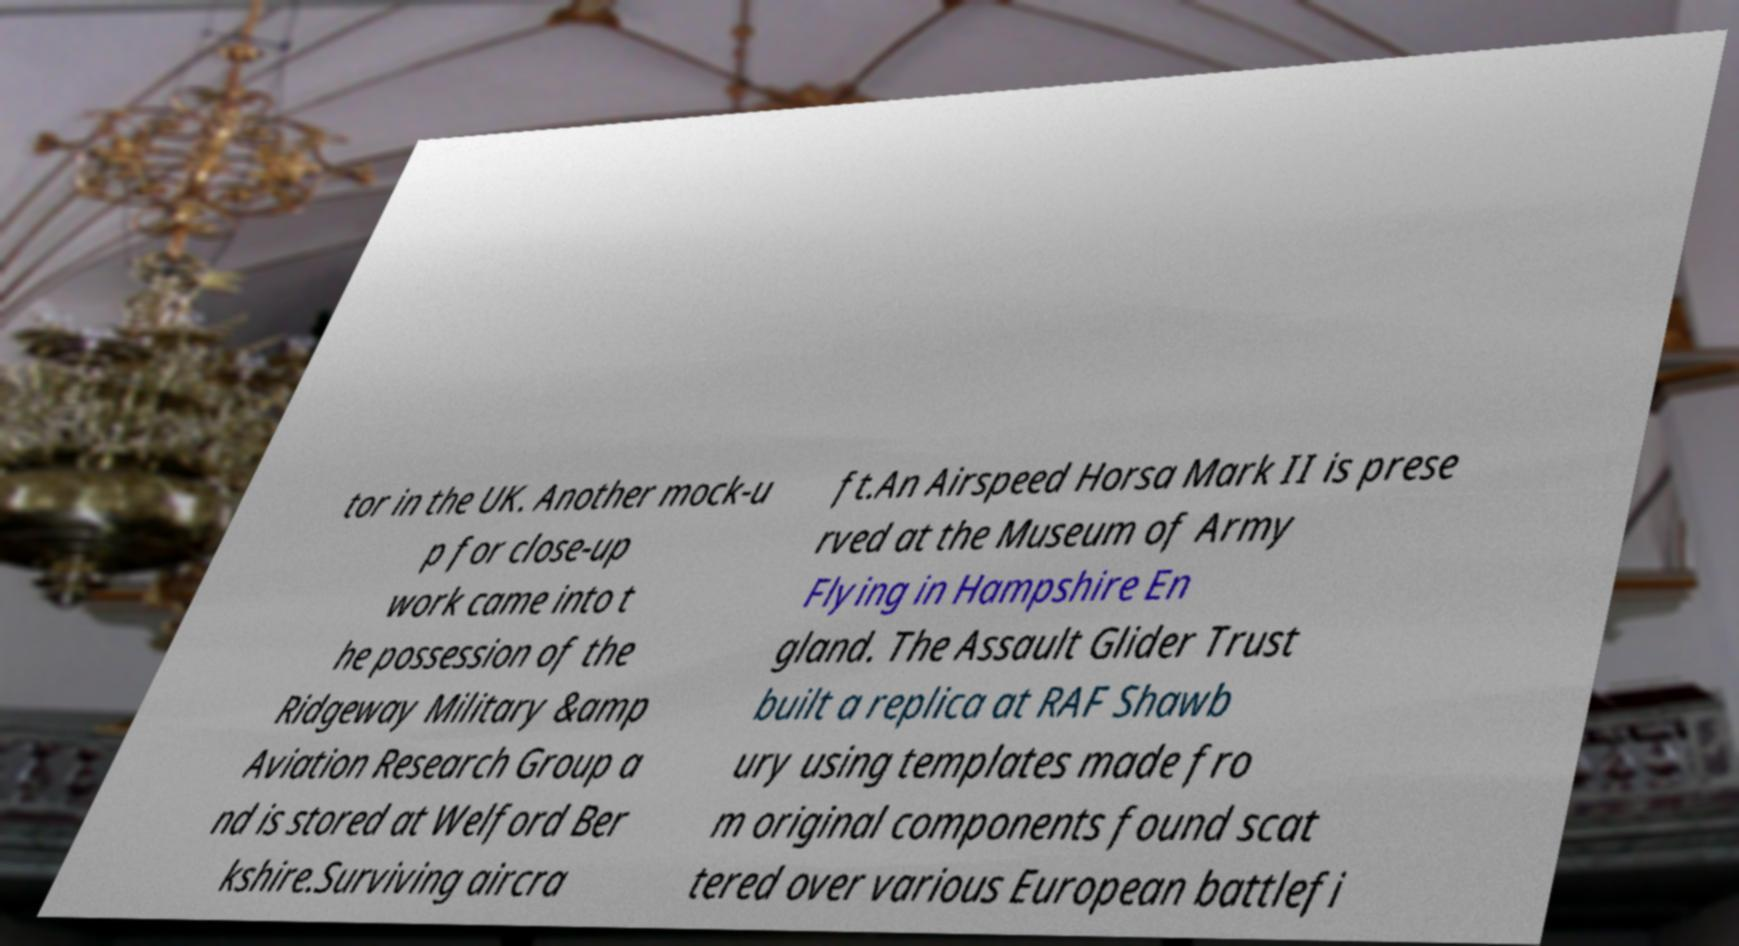Please identify and transcribe the text found in this image. tor in the UK. Another mock-u p for close-up work came into t he possession of the Ridgeway Military &amp Aviation Research Group a nd is stored at Welford Ber kshire.Surviving aircra ft.An Airspeed Horsa Mark II is prese rved at the Museum of Army Flying in Hampshire En gland. The Assault Glider Trust built a replica at RAF Shawb ury using templates made fro m original components found scat tered over various European battlefi 